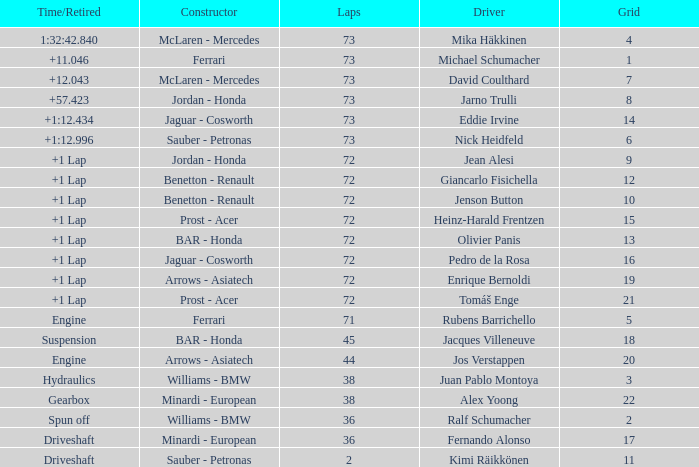Who is the constructor when the laps is more than 72 and the driver is eddie irvine? Jaguar - Cosworth. 